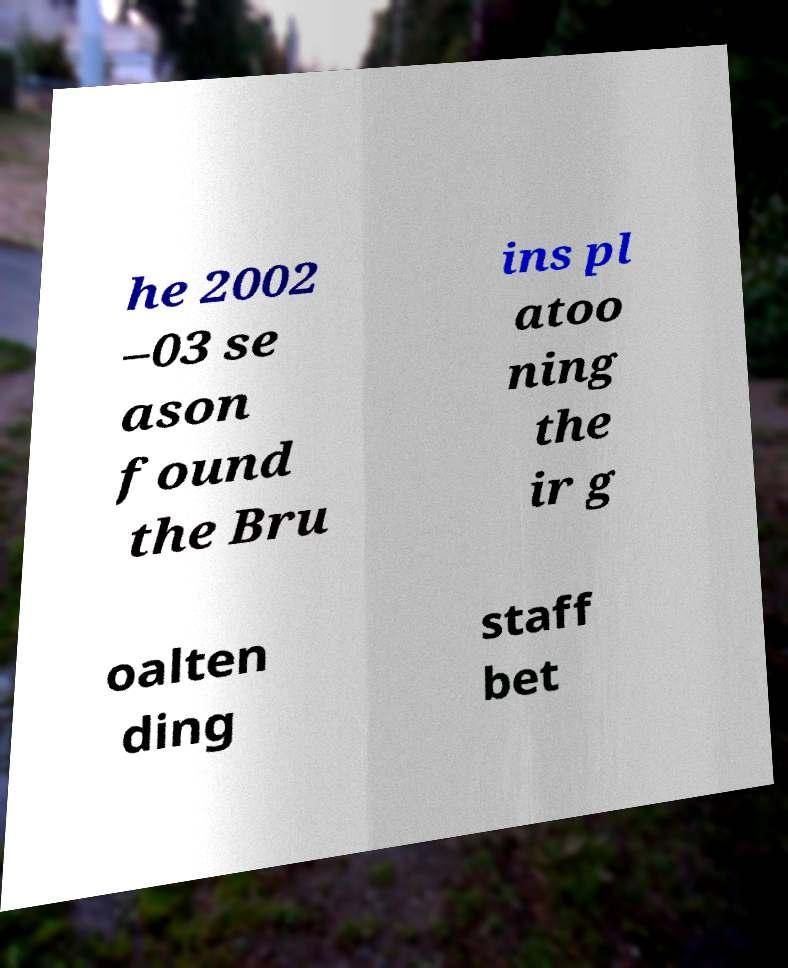Could you extract and type out the text from this image? he 2002 –03 se ason found the Bru ins pl atoo ning the ir g oalten ding staff bet 